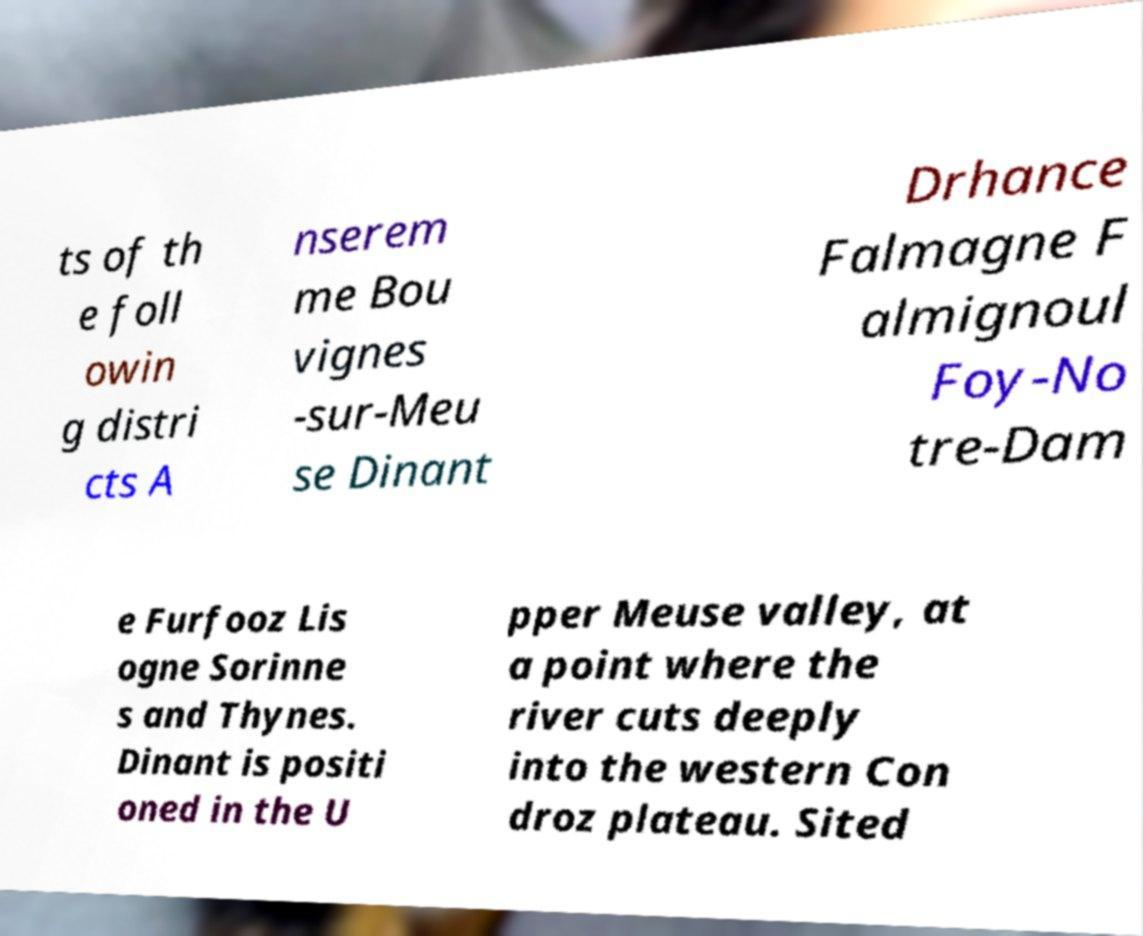Can you read and provide the text displayed in the image?This photo seems to have some interesting text. Can you extract and type it out for me? ts of th e foll owin g distri cts A nserem me Bou vignes -sur-Meu se Dinant Drhance Falmagne F almignoul Foy-No tre-Dam e Furfooz Lis ogne Sorinne s and Thynes. Dinant is positi oned in the U pper Meuse valley, at a point where the river cuts deeply into the western Con droz plateau. Sited 